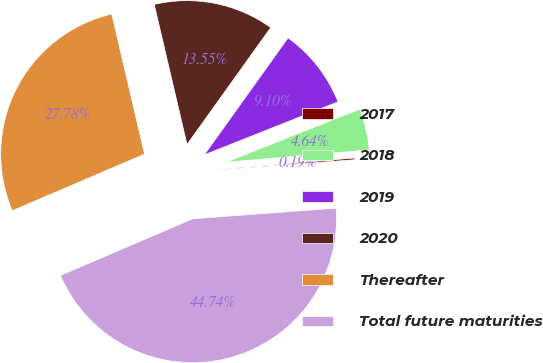Convert chart. <chart><loc_0><loc_0><loc_500><loc_500><pie_chart><fcel>2017<fcel>2018<fcel>2019<fcel>2020<fcel>Thereafter<fcel>Total future maturities<nl><fcel>0.19%<fcel>4.64%<fcel>9.1%<fcel>13.55%<fcel>27.78%<fcel>44.74%<nl></chart> 